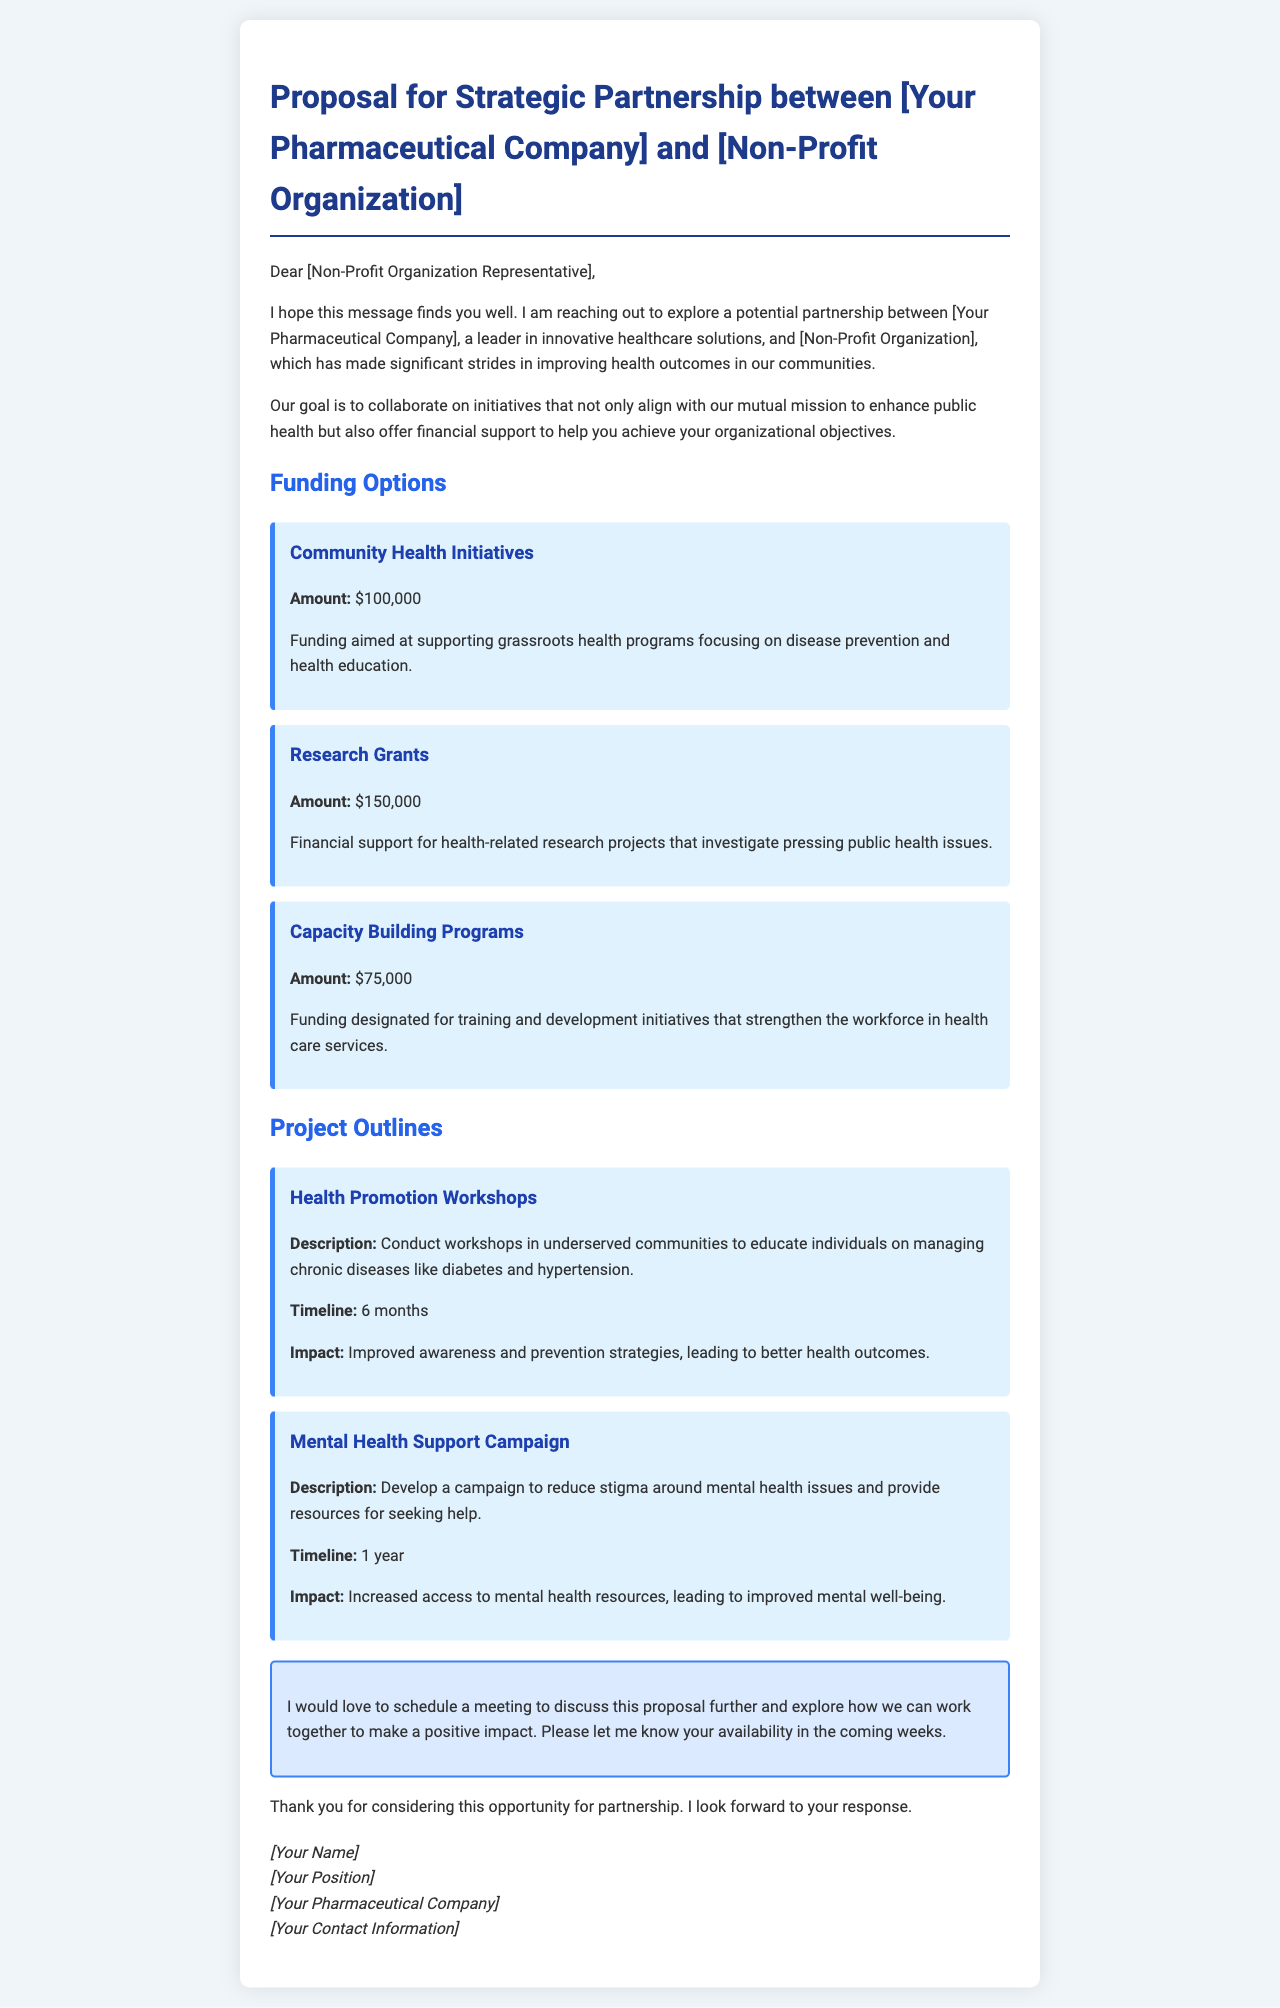What is the title of the proposal? The title of the proposal appears at the top of the document as the heading.
Answer: Proposal for Strategic Partnership between [Your Pharmaceutical Company] and [Non-Profit Organization] How much funding is allocated for Community Health Initiatives? The document specifies the amount allocated for each funding option.
Answer: $100,000 What is the timeline for the Health Promotion Workshops project? The timeline is mentioned in the project outline section of the document.
Answer: 6 months What is a goal of the proposed partnership? The goal is clearly stated in the introduction of the document.
Answer: Enhance public health How many funding options are listed in the document? The document lists several funding options, which can be counted from the section.
Answer: 3 What type of campaign is outlined in the project section? The description of the project includes specific types of campaigns.
Answer: Mental Health Support Campaign What is the impact of the Mental Health Support Campaign? The document specifies the expected outcome of this campaign.
Answer: Increased access to mental health resources Who should you contact for more information? The contact information is found in the signature section at the bottom of the document.
Answer: [Your Contact Information] 